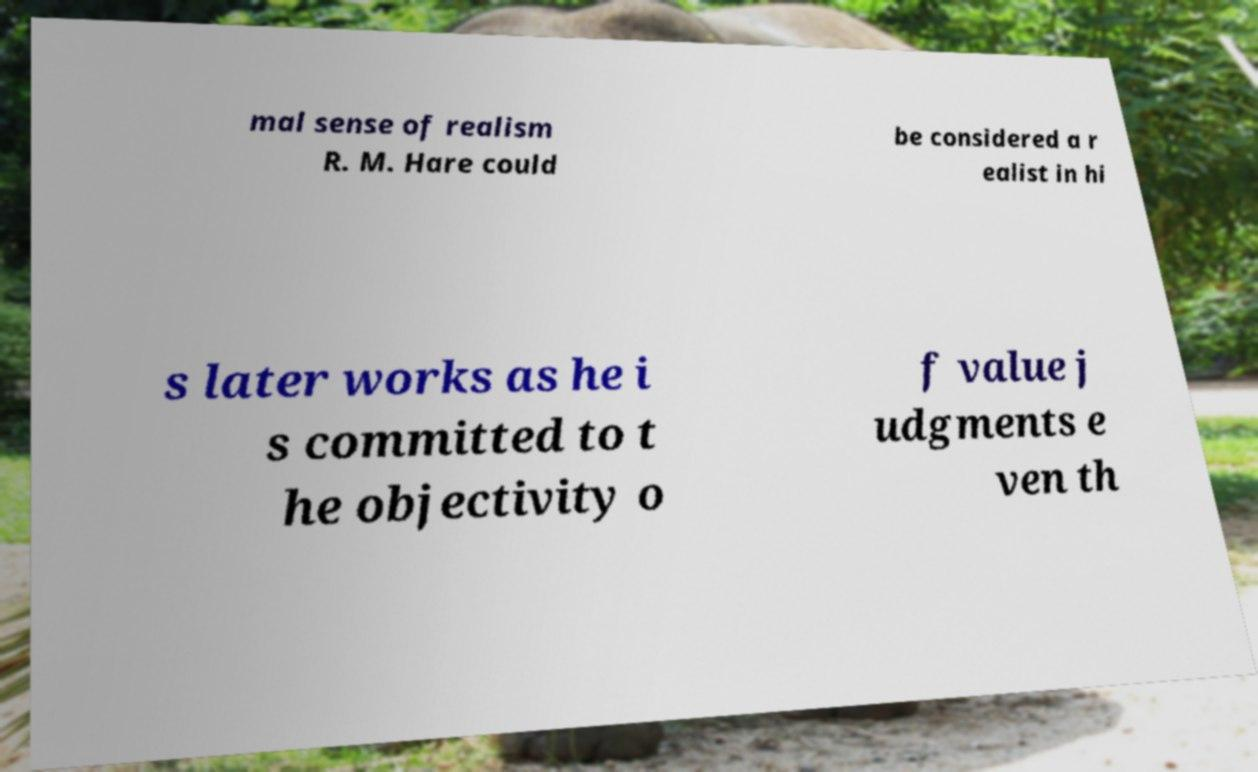Please identify and transcribe the text found in this image. mal sense of realism R. M. Hare could be considered a r ealist in hi s later works as he i s committed to t he objectivity o f value j udgments e ven th 